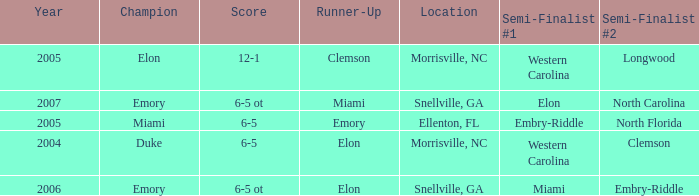When Embry-Riddle made it to the first semi finalist slot, list all the runners up. Emory. 